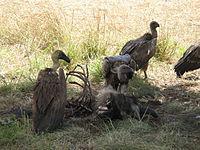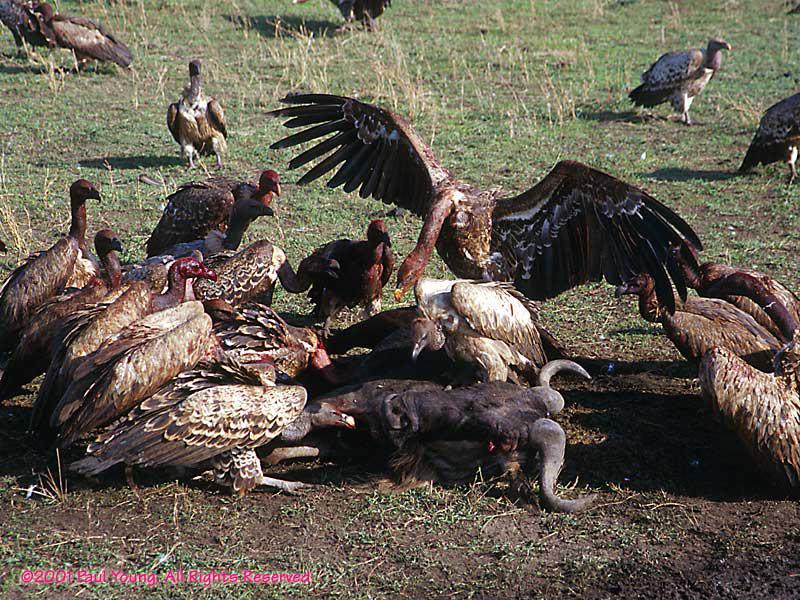The first image is the image on the left, the second image is the image on the right. Evaluate the accuracy of this statement regarding the images: "The sky can be seen in the image on the left". Is it true? Answer yes or no. No. 